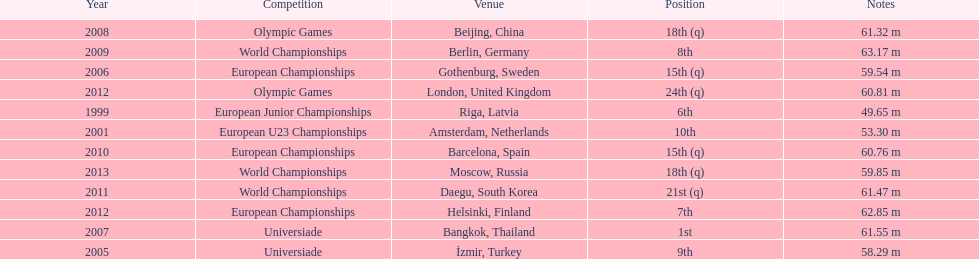Name two events in which mayer competed before he won the bangkok universiade. European Championships, Universiade. 